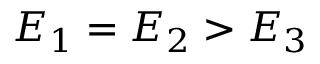<formula> <loc_0><loc_0><loc_500><loc_500>E _ { 1 } = E _ { 2 } > E _ { 3 }</formula> 